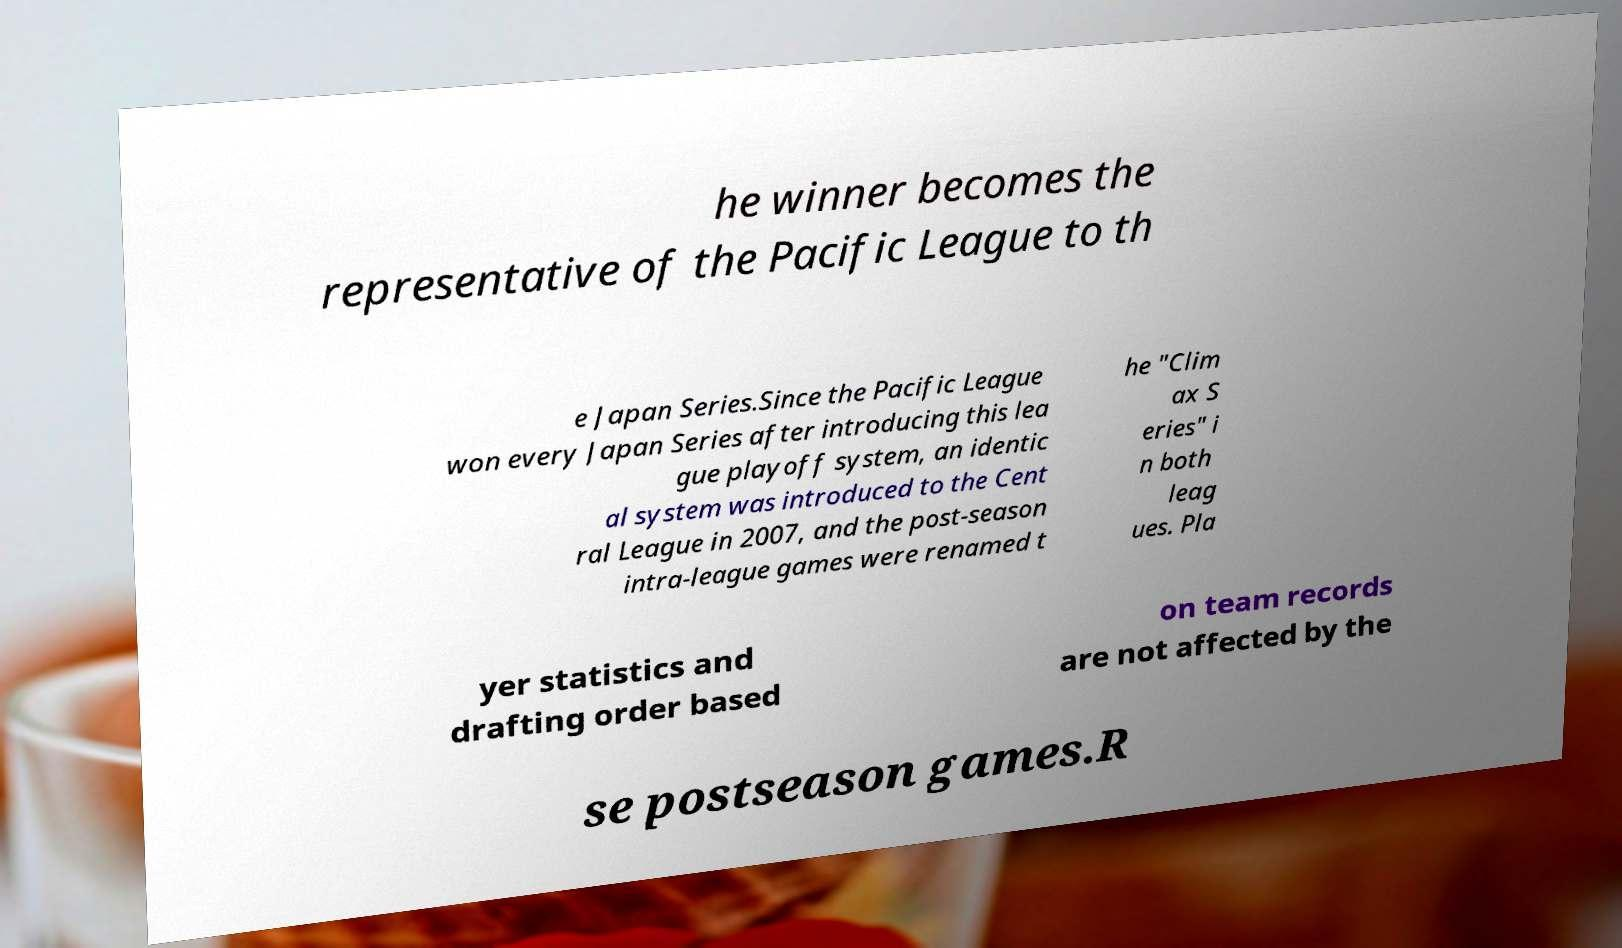Could you extract and type out the text from this image? he winner becomes the representative of the Pacific League to th e Japan Series.Since the Pacific League won every Japan Series after introducing this lea gue playoff system, an identic al system was introduced to the Cent ral League in 2007, and the post-season intra-league games were renamed t he "Clim ax S eries" i n both leag ues. Pla yer statistics and drafting order based on team records are not affected by the se postseason games.R 